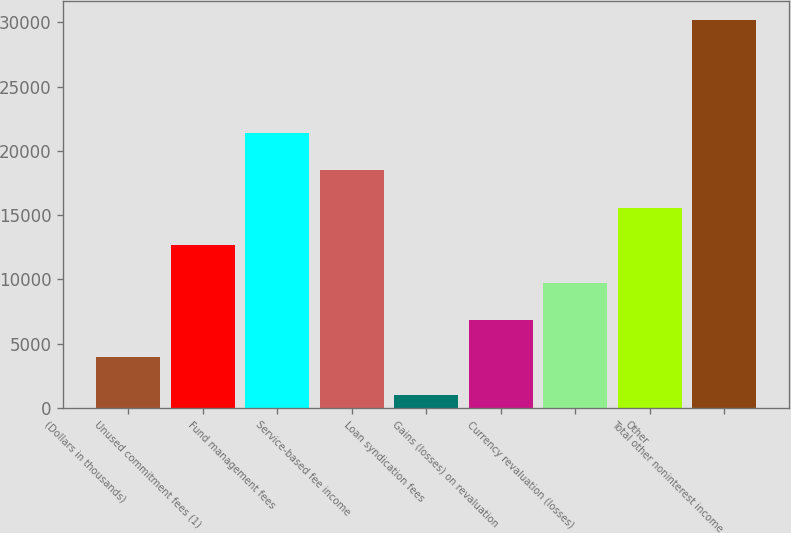Convert chart to OTSL. <chart><loc_0><loc_0><loc_500><loc_500><bar_chart><fcel>(Dollars in thousands)<fcel>Unused commitment fees (1)<fcel>Fund management fees<fcel>Service-based fee income<fcel>Loan syndication fees<fcel>Gains (losses) on revaluation<fcel>Currency revaluation (losses)<fcel>Other<fcel>Total other noninterest income<nl><fcel>3933.5<fcel>12674<fcel>21414.5<fcel>18501<fcel>1020<fcel>6847<fcel>9760.5<fcel>15587.5<fcel>30155<nl></chart> 